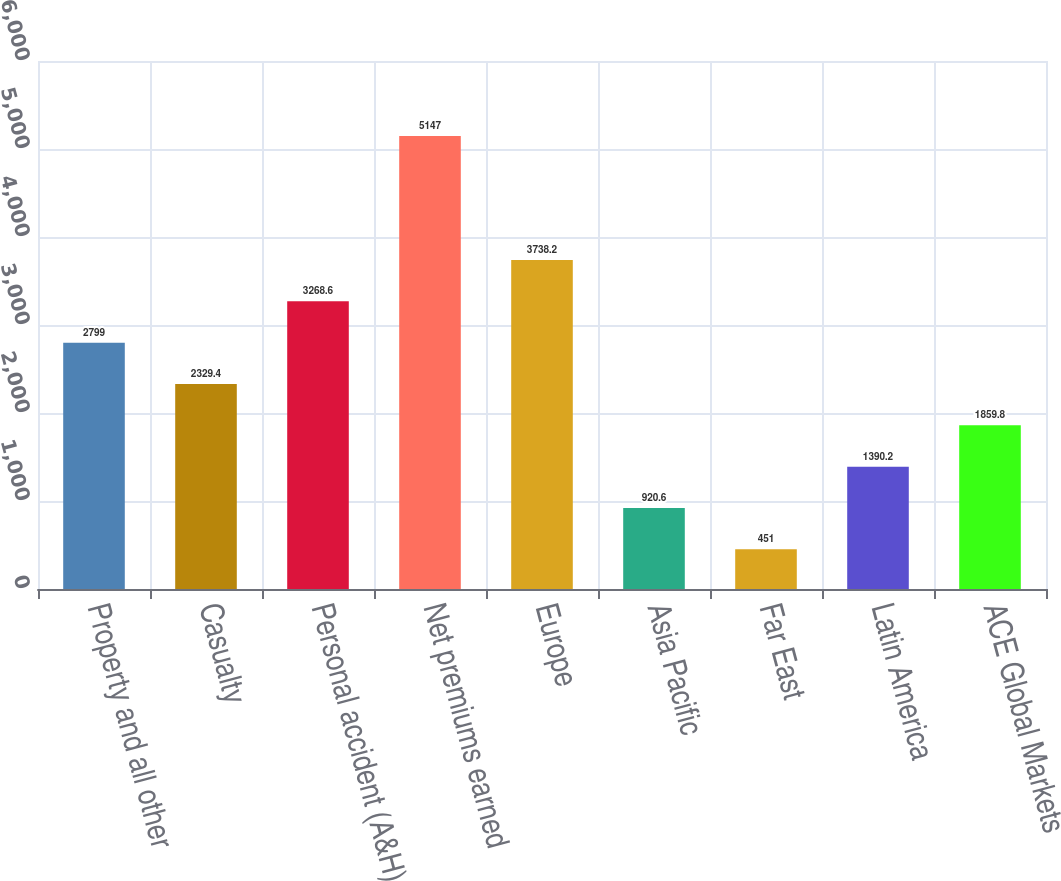Convert chart to OTSL. <chart><loc_0><loc_0><loc_500><loc_500><bar_chart><fcel>Property and all other<fcel>Casualty<fcel>Personal accident (A&H)<fcel>Net premiums earned<fcel>Europe<fcel>Asia Pacific<fcel>Far East<fcel>Latin America<fcel>ACE Global Markets<nl><fcel>2799<fcel>2329.4<fcel>3268.6<fcel>5147<fcel>3738.2<fcel>920.6<fcel>451<fcel>1390.2<fcel>1859.8<nl></chart> 